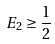<formula> <loc_0><loc_0><loc_500><loc_500>\, E _ { 2 } \geq \frac { 1 } { 2 }</formula> 